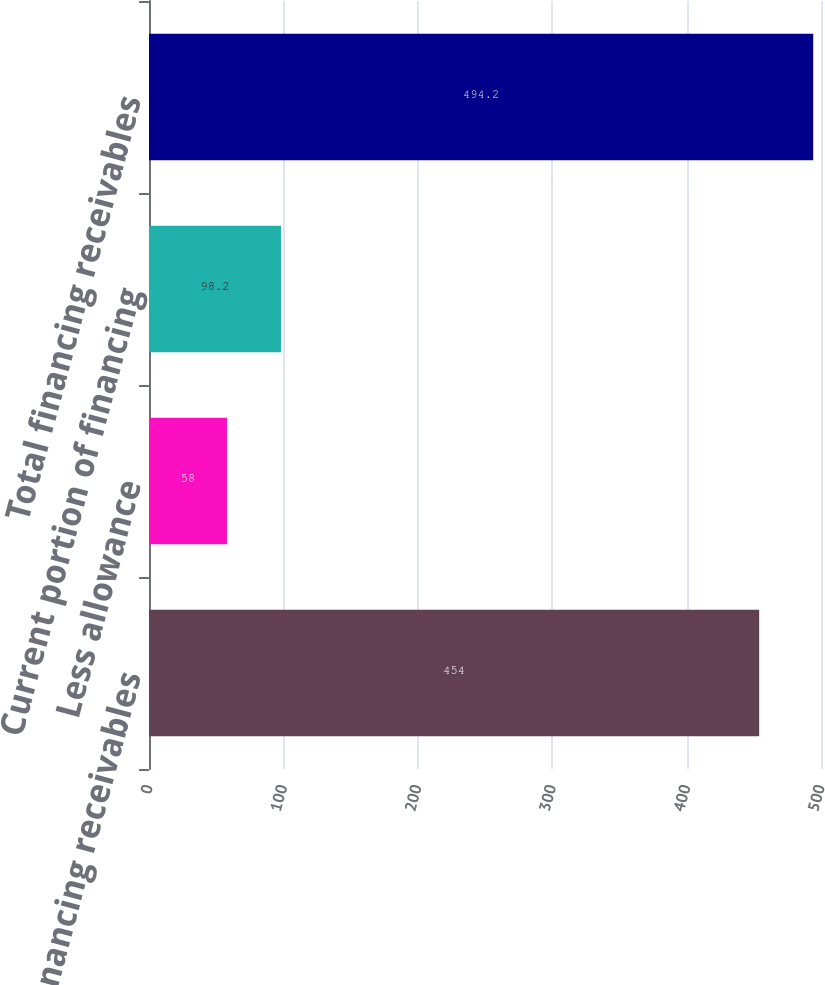Convert chart. <chart><loc_0><loc_0><loc_500><loc_500><bar_chart><fcel>Financing receivables<fcel>Less allowance<fcel>Current portion of financing<fcel>Total financing receivables<nl><fcel>454<fcel>58<fcel>98.2<fcel>494.2<nl></chart> 